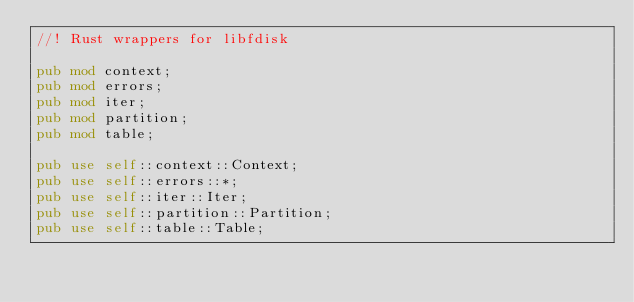Convert code to text. <code><loc_0><loc_0><loc_500><loc_500><_Rust_>//! Rust wrappers for libfdisk

pub mod context;
pub mod errors;
pub mod iter;
pub mod partition;
pub mod table;

pub use self::context::Context;
pub use self::errors::*;
pub use self::iter::Iter;
pub use self::partition::Partition;
pub use self::table::Table;
</code> 